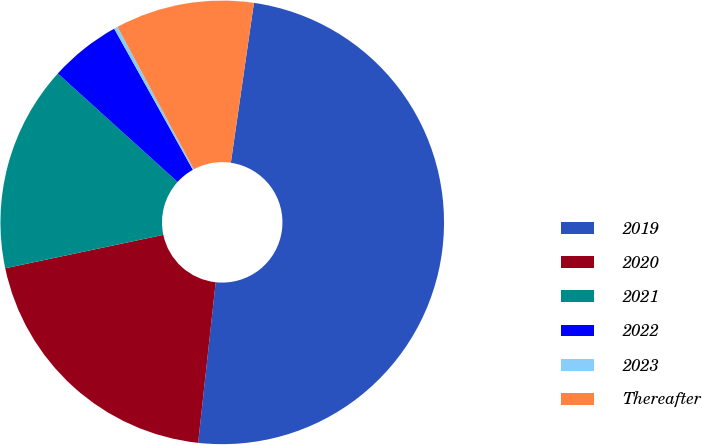Convert chart to OTSL. <chart><loc_0><loc_0><loc_500><loc_500><pie_chart><fcel>2019<fcel>2020<fcel>2021<fcel>2022<fcel>2023<fcel>Thereafter<nl><fcel>49.45%<fcel>19.95%<fcel>15.03%<fcel>5.19%<fcel>0.27%<fcel>10.11%<nl></chart> 